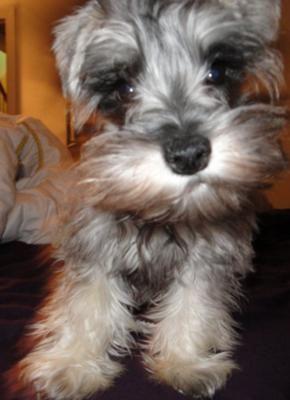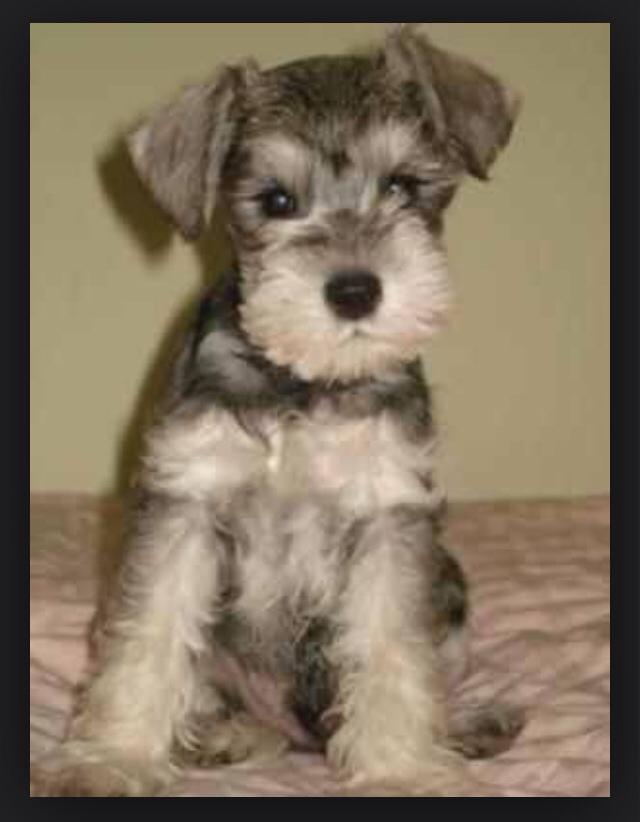The first image is the image on the left, the second image is the image on the right. Given the left and right images, does the statement "One of the dogs is wearing a round tag on its collar." hold true? Answer yes or no. No. The first image is the image on the left, the second image is the image on the right. Given the left and right images, does the statement "Each image shows a schnauzer with light-colored 'mustache and beard' fur, and each dog faces the camera with eyes visible." hold true? Answer yes or no. Yes. 